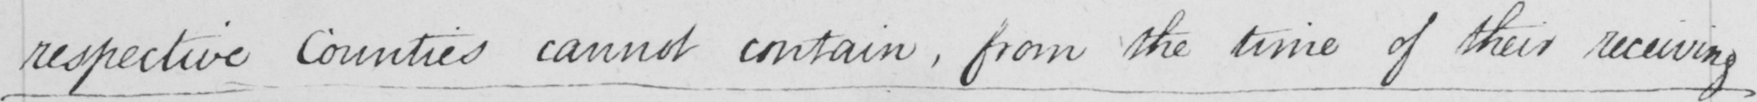What text is written in this handwritten line? respective Counties cannot contain , from the time of their receiving 